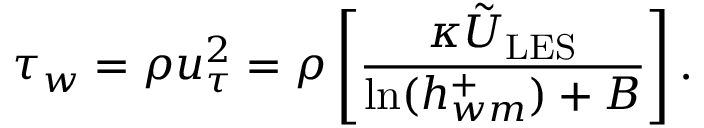<formula> <loc_0><loc_0><loc_500><loc_500>\tau _ { w } = \rho u _ { \tau } ^ { 2 } = \rho \left [ \frac { \kappa \tilde { U } _ { L E S } } { \ln ( h _ { w m } ^ { + } ) + B } \right ] .</formula> 